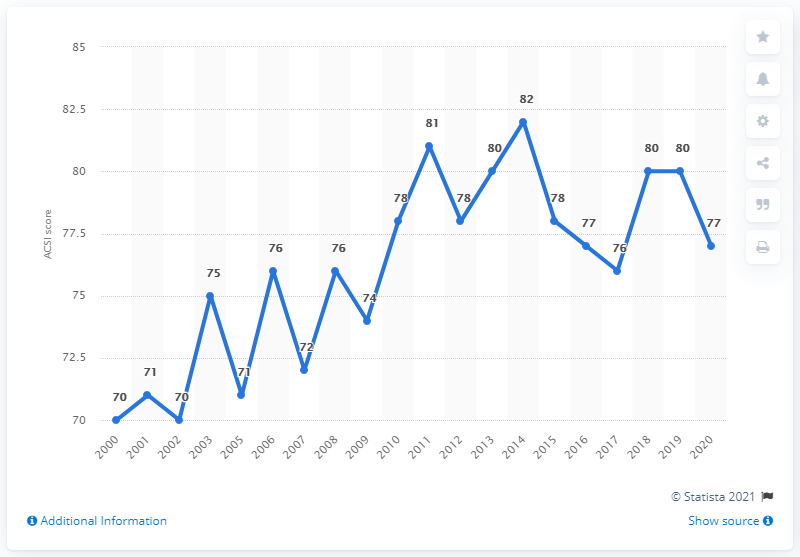Outline some significant characteristics in this image. Pizza Hut's ACSI (American Customer Satisfaction Index) score in 2020 was 77 out of 100, indicating a high level of customer satisfaction with the company. 